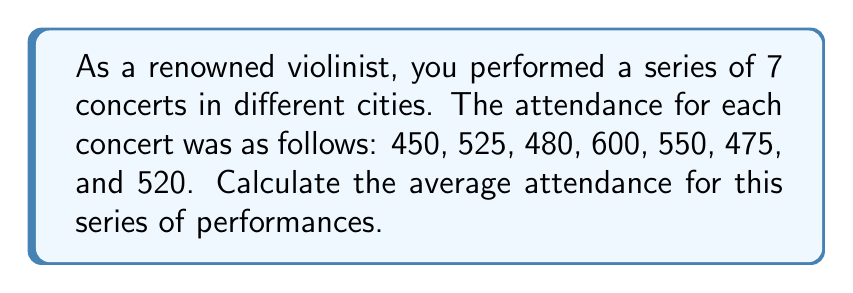Give your solution to this math problem. To calculate the average attendance, we need to follow these steps:

1. Sum up the attendance for all concerts:
   $450 + 525 + 480 + 600 + 550 + 475 + 520 = 3600$

2. Count the total number of concerts:
   There are 7 concerts in total.

3. Apply the formula for average:
   $\text{Average} = \frac{\text{Sum of all values}}{\text{Number of values}}$

4. Substitute the values:
   $$\text{Average attendance} = \frac{3600}{7}$$

5. Perform the division:
   $$\text{Average attendance} = 514.2857...$$

6. Round to the nearest whole number (since we can't have a fractional person):
   $$\text{Average attendance} \approx 514$$

Therefore, the average attendance for your series of 7 concerts was 514 people.
Answer: 514 people 